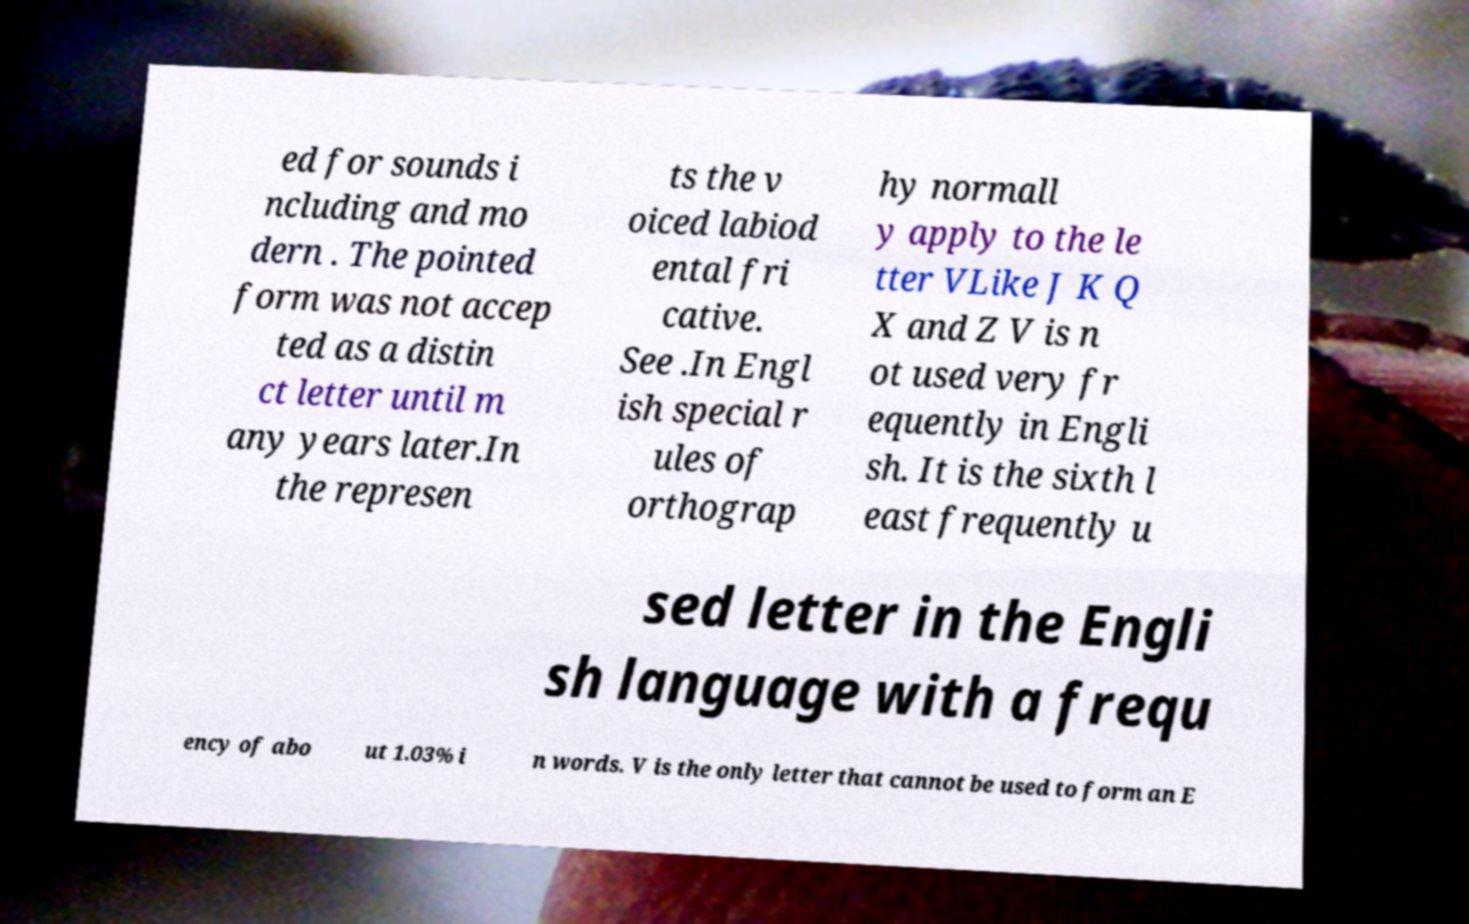Can you accurately transcribe the text from the provided image for me? ed for sounds i ncluding and mo dern . The pointed form was not accep ted as a distin ct letter until m any years later.In the represen ts the v oiced labiod ental fri cative. See .In Engl ish special r ules of orthograp hy normall y apply to the le tter VLike J K Q X and Z V is n ot used very fr equently in Engli sh. It is the sixth l east frequently u sed letter in the Engli sh language with a frequ ency of abo ut 1.03% i n words. V is the only letter that cannot be used to form an E 